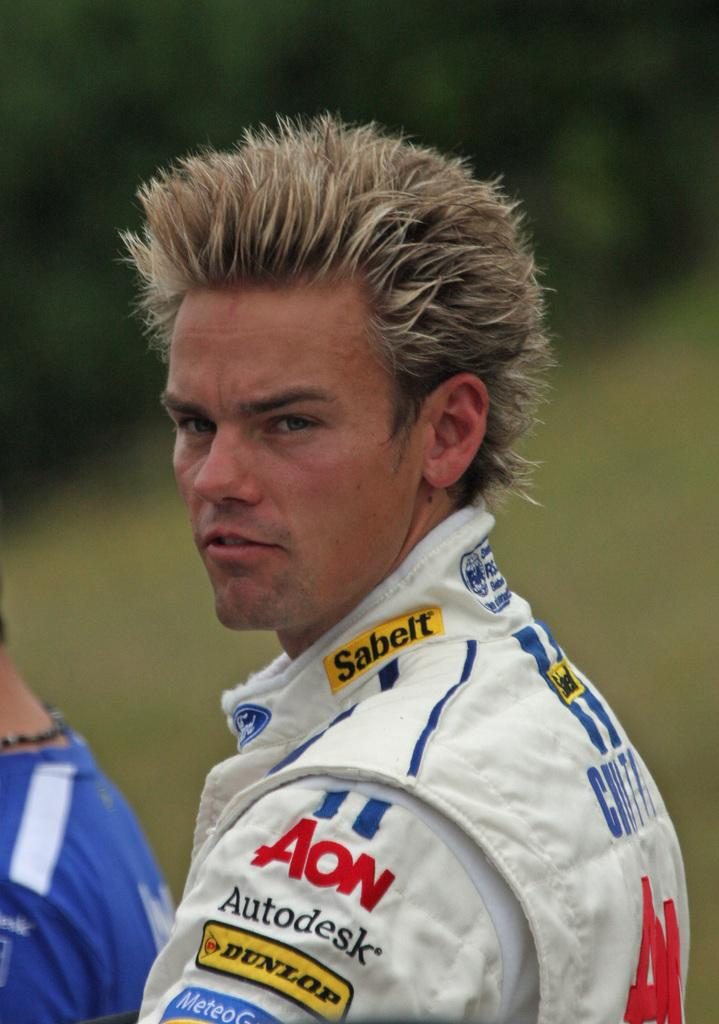<image>
Create a compact narrative representing the image presented. a man with spiked hair an Autodesk on his shirt 